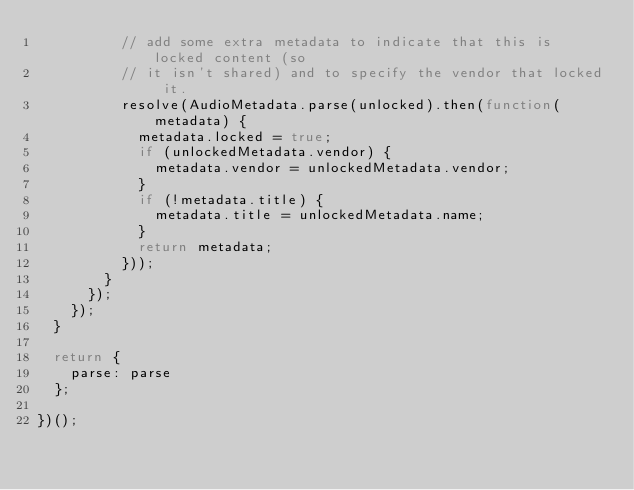<code> <loc_0><loc_0><loc_500><loc_500><_JavaScript_>          // add some extra metadata to indicate that this is locked content (so
          // it isn't shared) and to specify the vendor that locked it.
          resolve(AudioMetadata.parse(unlocked).then(function(metadata) {
            metadata.locked = true;
            if (unlockedMetadata.vendor) {
              metadata.vendor = unlockedMetadata.vendor;
            }
            if (!metadata.title) {
              metadata.title = unlockedMetadata.name;
            }
            return metadata;
          }));
        }
      });
    });
  }

  return {
    parse: parse
  };

})();
</code> 